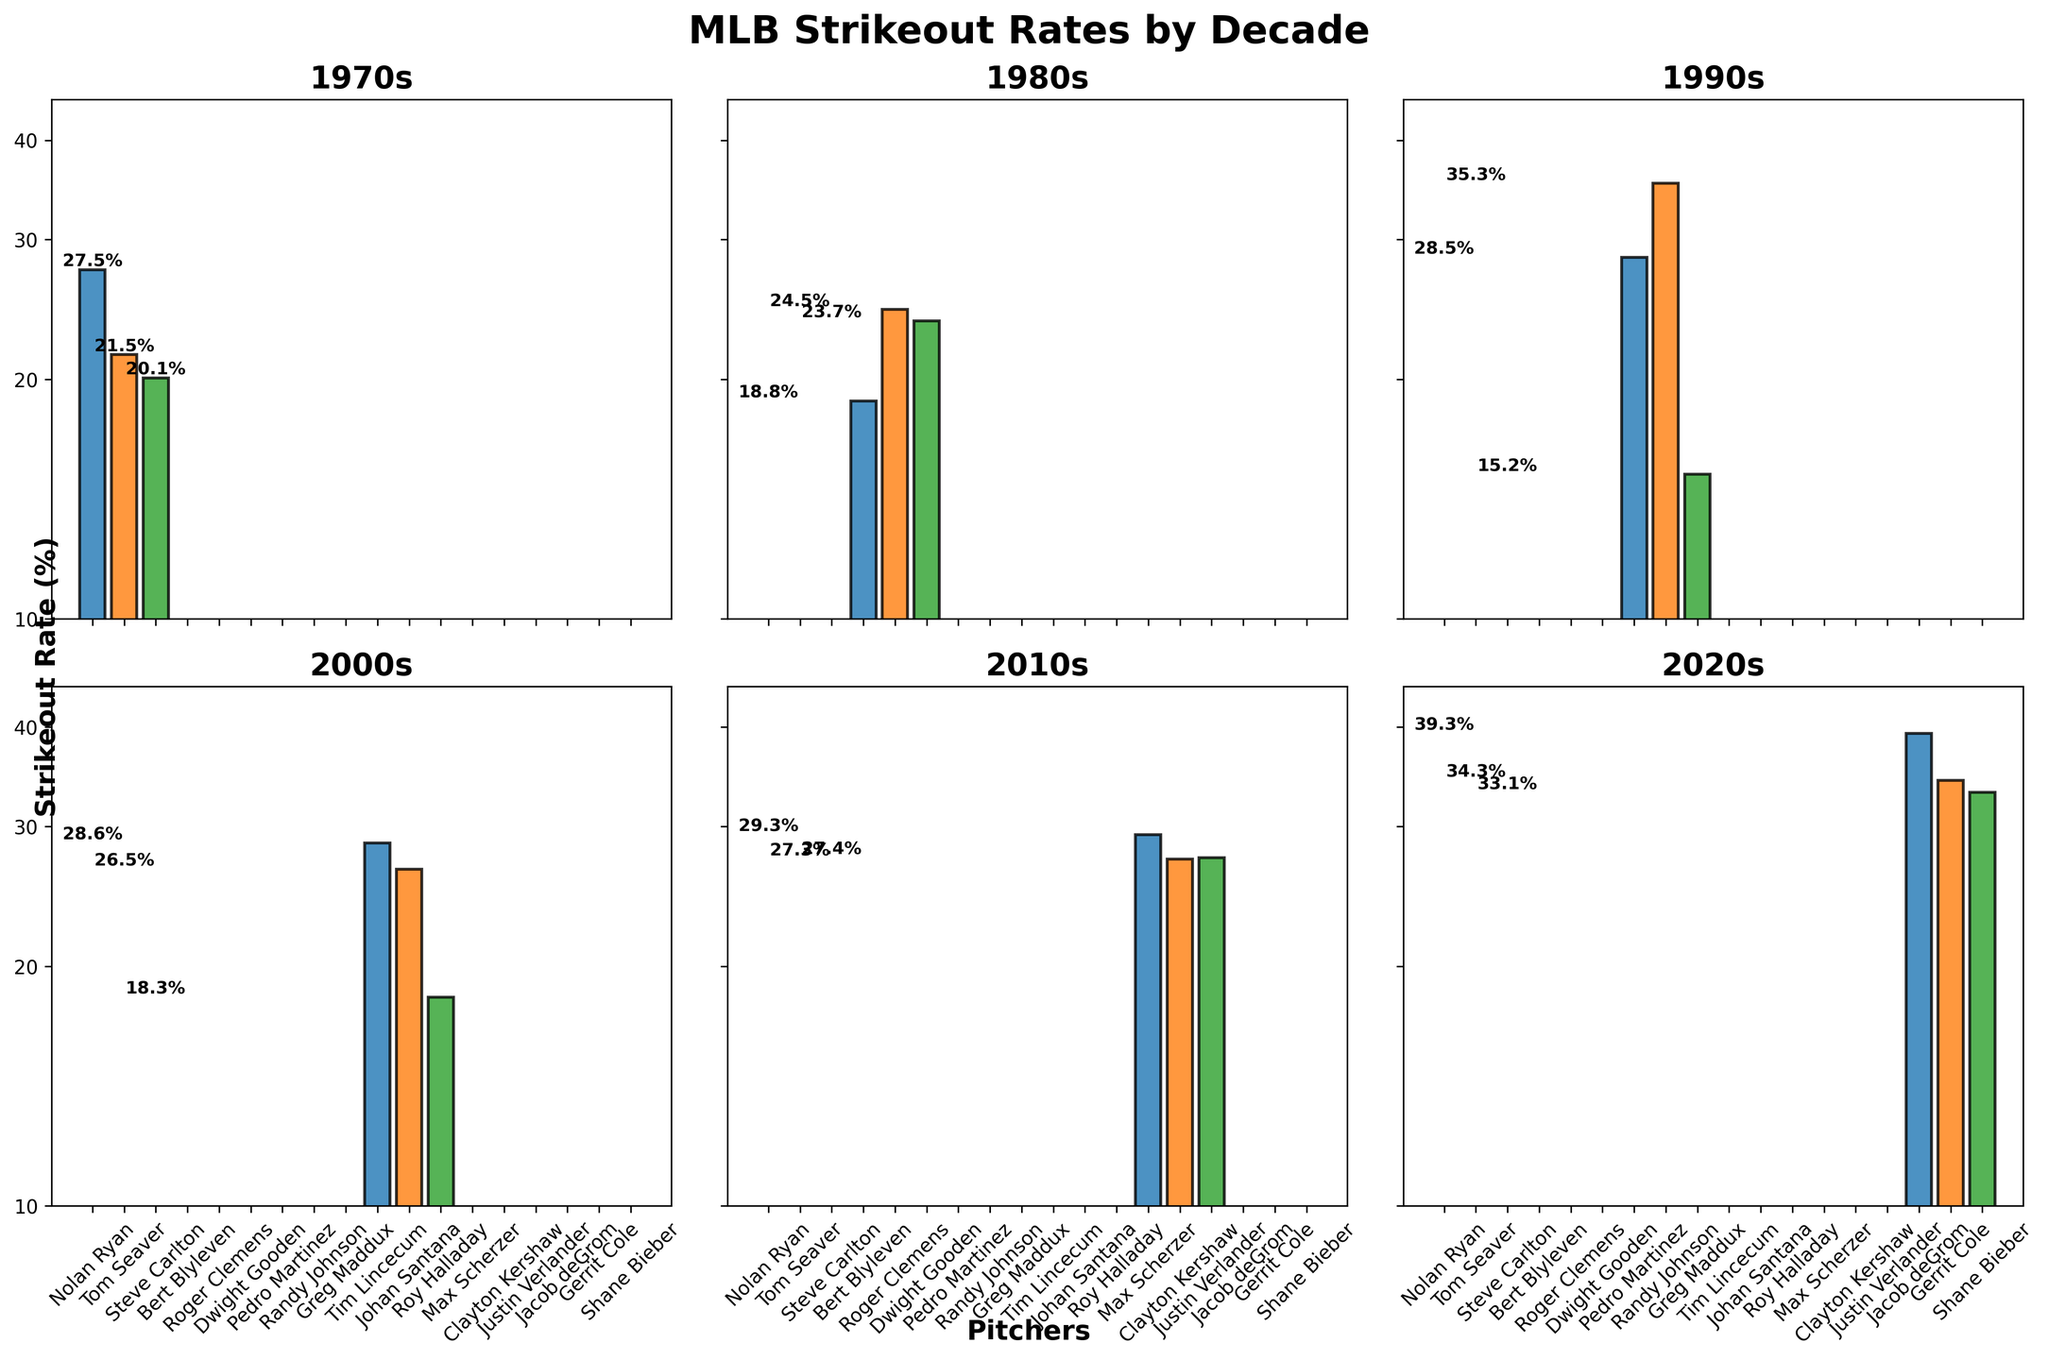Which decade shows the highest range of strikeout rates? To determine the highest range of strikeout rates, observe the max and min values on the y-axis for each decade. The 2020s have the highest range, with the highest being 39.3% and the lowest being 33.1%, resulting in a range of 6.2%.
Answer: The 2020s What is the strikeout rate of Jacob deGrom? Look at the bar for Jacob deGrom in the subplot for the 2020s. The text annotation on the bar indicates a strikeout rate of 39.3%.
Answer: 39.3% Which pitcher has the lowest strikeout rate in the 2010s? Check the subplot for the 2010s and compare the bars for Max Scherzer, Clayton Kershaw, and Justin Verlander. Justin Verlander has the lowest strikeout rate at 27.4%.
Answer: Justin Verlander Among Nolan Ryan, Tom Seaver, and Steve Carlton, who has the highest strikeout rate in the 1970s? Look at the subplot for the 1970s and compare the bars. Nolan Ryan has the highest strikeout rate at 27.5%.
Answer: Nolan Ryan How much higher is Randy Johnson's strikeout rate compared to Greg Maddux's in the 1990s? Find the bars for Randy Johnson and Greg Maddux in the 1990s subplot. Randy Johnson's rate is 35.3%, and Greg Maddux's rate is 15.2%. Subtract Maddux's rate from Johnson's: 35.3% - 15.2% = 20.1%.
Answer: 20.1% Compare the average strikeout rates of the pitchers in the 1980s and 2000s. Which decade has the higher average? Calculate the average for the 1980s: (18.8 + 24.5 + 23.7) / 3 = 22.333%. For the 2000s: (28.6 + 26.5 + 18.3) / 3 = 24.467%. The 2000s have a higher average at 24.467%.
Answer: 2000s Which decade demonstrates the greatest variance in strikeout rates within its pitchers? Visually assess each subplot for variability. The 2020s demonstrate the greatest variance ranging from Shane Bieber's 33.1% to Jacob deGrom's 39.3%. This can be evaluated more formally by calculating variance, but visibly, this range indicates significant variability.
Answer: 2020s What is the purpose of using a log scale for the y-axis in this strikeout rates figure? A log scale is used to better visualize data that varies over a large range, making it easier to compare percentages close to each other and also those that are significantly different. It helps in seeing the differences in lower and higher ranges more clearly.
Answer: To better visualize data over a wide range Among all decades, which one has the highest individual strikeout rate, and who is the pitcher? Identify the highest single bar across all subplots. Jacob deGrom in the 2020s has the highest strikeout rate of 39.3%.
Answer: 2020s; Jacob deGrom 